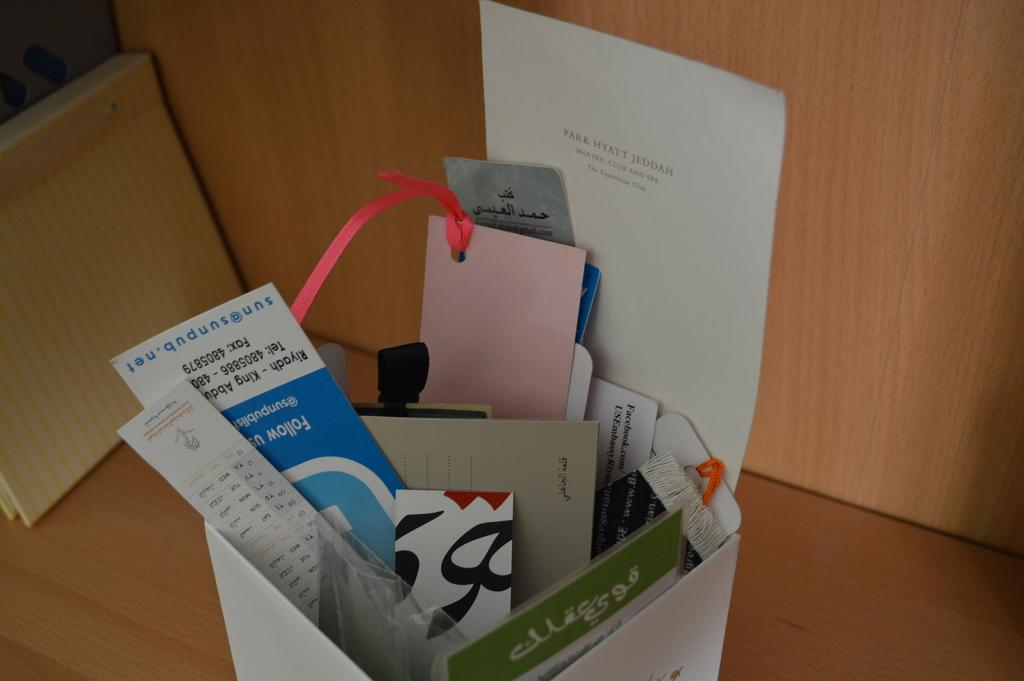Provide a one-sentence caption for the provided image. A piece of paper displays the text 'Park Hyatt Jeddah'. 